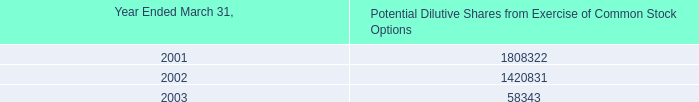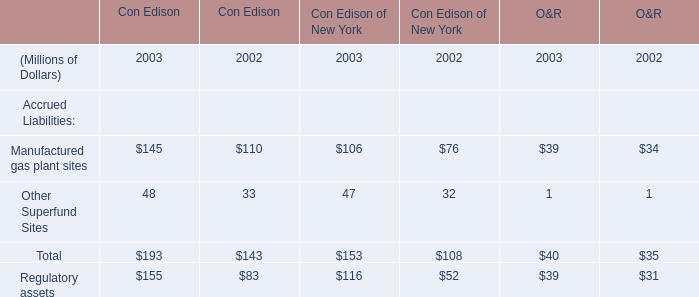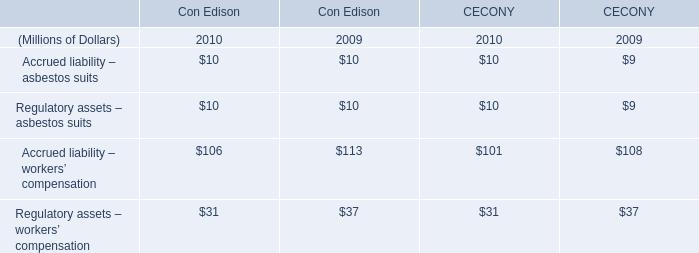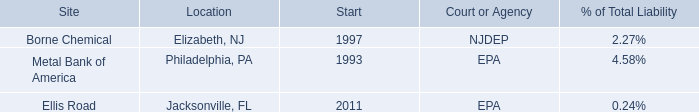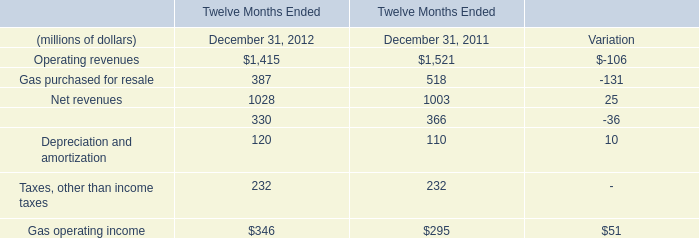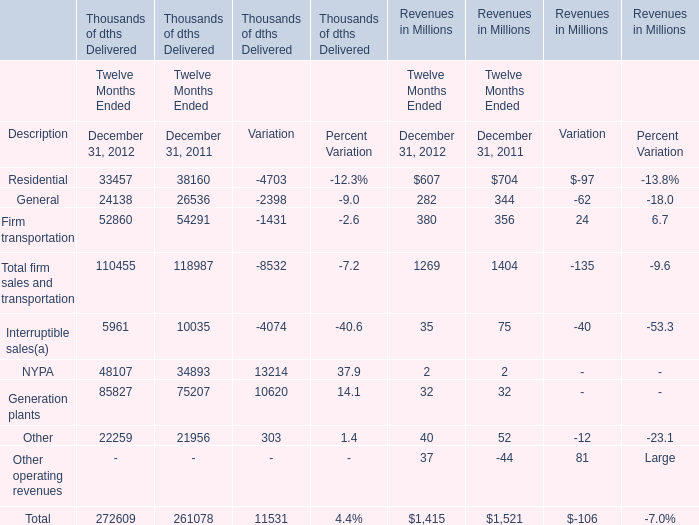What is the sum of Twelve Months Ended in the range of 50000 and 80000 in 2012 for Thousands of dths Delivered? (in Thousand) 
Computations: (85827 + 52860)
Answer: 138687.0. 